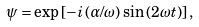<formula> <loc_0><loc_0><loc_500><loc_500>\psi = \exp \left [ - i \left ( \alpha / \omega \right ) \sin \left ( 2 \omega t \right ) \right ] ,</formula> 